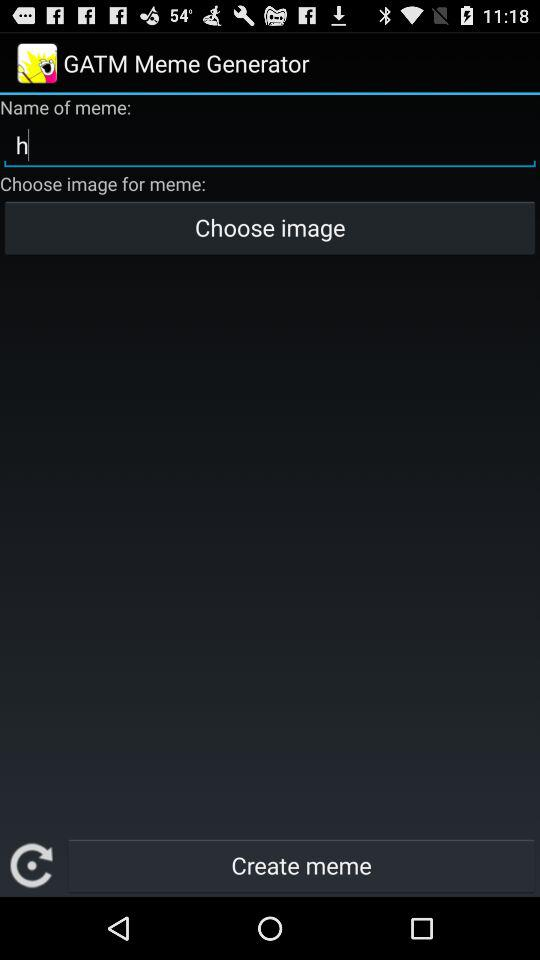What is the name of the application? The name of the application is "GATM Meme Generator". 